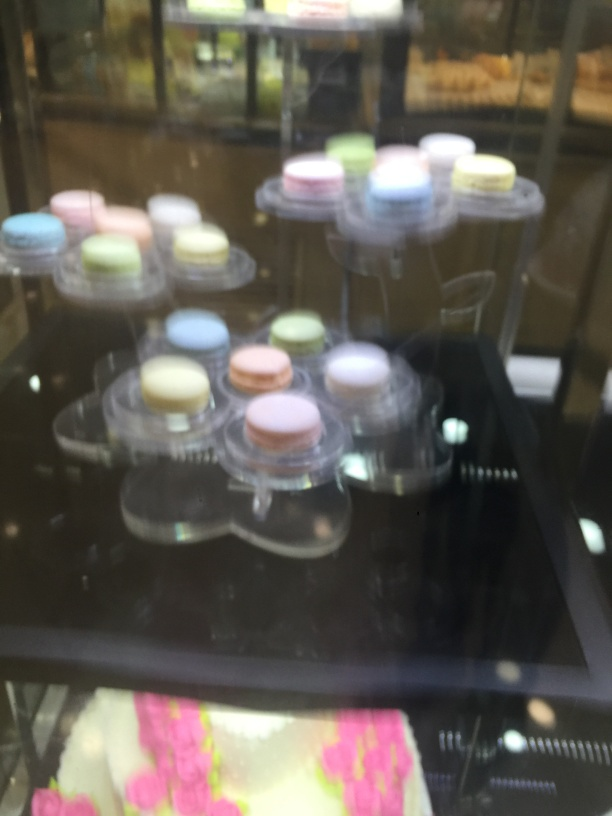What is the level of motion blur in the image?
A. some trailing
B. slight trailing
C. intense motion blur
Answer with the option's letter from the given choices directly. The image shows a noticeable amount of motion blur affecting the clarity of the subjects, which appear to be pastries displayed behind a glass enclosure. While the blur does not entirely obscure the objects, it's significant enough to suggest a moderate level of movement at the time of capture or a low shutter speed during the photo. Therefore, the most suitable answer describing the level of motion blur present would be option A, indicating some trailing. 